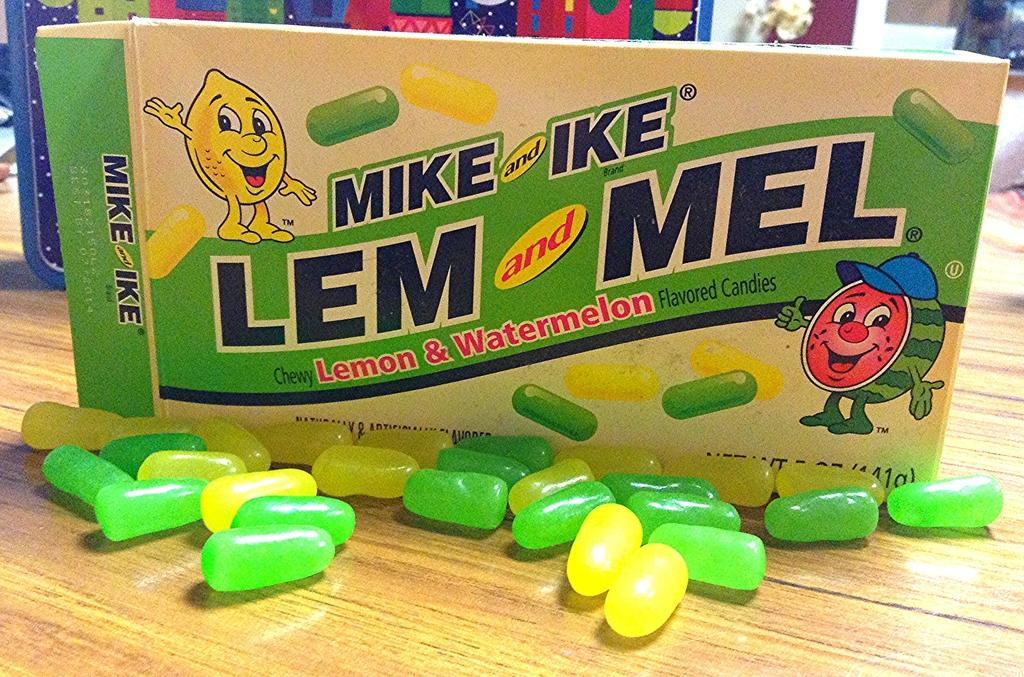What is the main subject of the image? The main subject of the image is a flavored candies pack. Where are the candies located in the image? Candies are visible on a wooden surface in the image. What can be seen in the background of the image? There are objects in the background of the image. Can you tell me how many hairs are on the candies in the image? There are no hairs visible on the candies in the image. What type of tray is used to hold the candies in the image? There is no tray present in the image; the candies are on a wooden surface. 